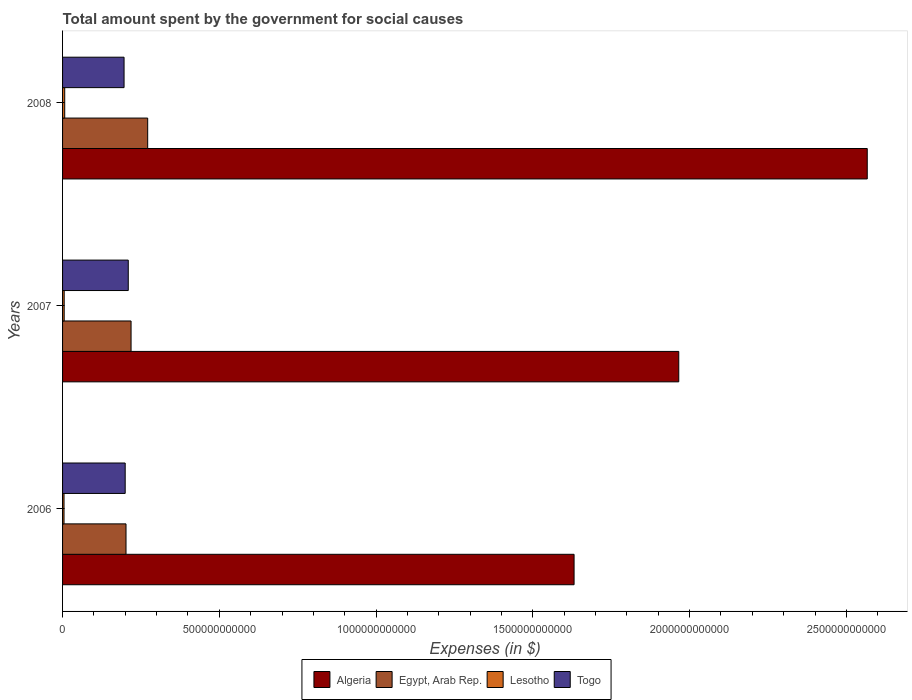How many different coloured bars are there?
Offer a terse response. 4. Are the number of bars per tick equal to the number of legend labels?
Provide a short and direct response. Yes. Are the number of bars on each tick of the Y-axis equal?
Give a very brief answer. Yes. How many bars are there on the 2nd tick from the top?
Make the answer very short. 4. How many bars are there on the 3rd tick from the bottom?
Ensure brevity in your answer.  4. What is the label of the 2nd group of bars from the top?
Keep it short and to the point. 2007. In how many cases, is the number of bars for a given year not equal to the number of legend labels?
Keep it short and to the point. 0. What is the amount spent for social causes by the government in Togo in 2008?
Your response must be concise. 1.96e+11. Across all years, what is the maximum amount spent for social causes by the government in Lesotho?
Keep it short and to the point. 6.87e+09. Across all years, what is the minimum amount spent for social causes by the government in Togo?
Your answer should be compact. 1.96e+11. What is the total amount spent for social causes by the government in Lesotho in the graph?
Provide a succinct answer. 1.67e+1. What is the difference between the amount spent for social causes by the government in Algeria in 2007 and that in 2008?
Offer a very short reply. -6.01e+11. What is the difference between the amount spent for social causes by the government in Togo in 2008 and the amount spent for social causes by the government in Egypt, Arab Rep. in 2007?
Make the answer very short. -2.23e+1. What is the average amount spent for social causes by the government in Egypt, Arab Rep. per year?
Provide a succinct answer. 2.31e+11. In the year 2007, what is the difference between the amount spent for social causes by the government in Egypt, Arab Rep. and amount spent for social causes by the government in Togo?
Your response must be concise. 8.93e+09. In how many years, is the amount spent for social causes by the government in Egypt, Arab Rep. greater than 600000000000 $?
Provide a short and direct response. 0. What is the ratio of the amount spent for social causes by the government in Lesotho in 2006 to that in 2008?
Provide a succinct answer. 0.68. Is the amount spent for social causes by the government in Egypt, Arab Rep. in 2006 less than that in 2008?
Give a very brief answer. Yes. Is the difference between the amount spent for social causes by the government in Egypt, Arab Rep. in 2006 and 2007 greater than the difference between the amount spent for social causes by the government in Togo in 2006 and 2007?
Provide a succinct answer. No. What is the difference between the highest and the second highest amount spent for social causes by the government in Algeria?
Offer a very short reply. 6.01e+11. What is the difference between the highest and the lowest amount spent for social causes by the government in Algeria?
Your response must be concise. 9.35e+11. Is it the case that in every year, the sum of the amount spent for social causes by the government in Togo and amount spent for social causes by the government in Egypt, Arab Rep. is greater than the sum of amount spent for social causes by the government in Lesotho and amount spent for social causes by the government in Algeria?
Give a very brief answer. No. What does the 3rd bar from the top in 2007 represents?
Keep it short and to the point. Egypt, Arab Rep. What does the 3rd bar from the bottom in 2006 represents?
Ensure brevity in your answer.  Lesotho. Is it the case that in every year, the sum of the amount spent for social causes by the government in Lesotho and amount spent for social causes by the government in Togo is greater than the amount spent for social causes by the government in Egypt, Arab Rep.?
Your answer should be very brief. No. How many bars are there?
Ensure brevity in your answer.  12. What is the difference between two consecutive major ticks on the X-axis?
Your answer should be compact. 5.00e+11. Are the values on the major ticks of X-axis written in scientific E-notation?
Provide a succinct answer. No. Does the graph contain any zero values?
Your response must be concise. No. How are the legend labels stacked?
Provide a short and direct response. Horizontal. What is the title of the graph?
Offer a terse response. Total amount spent by the government for social causes. What is the label or title of the X-axis?
Keep it short and to the point. Expenses (in $). What is the Expenses (in $) of Algeria in 2006?
Provide a short and direct response. 1.63e+12. What is the Expenses (in $) in Egypt, Arab Rep. in 2006?
Offer a terse response. 2.02e+11. What is the Expenses (in $) of Lesotho in 2006?
Ensure brevity in your answer.  4.65e+09. What is the Expenses (in $) in Togo in 2006?
Give a very brief answer. 2.00e+11. What is the Expenses (in $) in Algeria in 2007?
Your response must be concise. 1.97e+12. What is the Expenses (in $) in Egypt, Arab Rep. in 2007?
Provide a short and direct response. 2.18e+11. What is the Expenses (in $) in Lesotho in 2007?
Keep it short and to the point. 5.18e+09. What is the Expenses (in $) of Togo in 2007?
Your response must be concise. 2.10e+11. What is the Expenses (in $) in Algeria in 2008?
Your response must be concise. 2.57e+12. What is the Expenses (in $) of Egypt, Arab Rep. in 2008?
Make the answer very short. 2.71e+11. What is the Expenses (in $) in Lesotho in 2008?
Your answer should be compact. 6.87e+09. What is the Expenses (in $) of Togo in 2008?
Ensure brevity in your answer.  1.96e+11. Across all years, what is the maximum Expenses (in $) in Algeria?
Provide a short and direct response. 2.57e+12. Across all years, what is the maximum Expenses (in $) of Egypt, Arab Rep.?
Provide a succinct answer. 2.71e+11. Across all years, what is the maximum Expenses (in $) of Lesotho?
Make the answer very short. 6.87e+09. Across all years, what is the maximum Expenses (in $) of Togo?
Make the answer very short. 2.10e+11. Across all years, what is the minimum Expenses (in $) in Algeria?
Give a very brief answer. 1.63e+12. Across all years, what is the minimum Expenses (in $) of Egypt, Arab Rep.?
Give a very brief answer. 2.02e+11. Across all years, what is the minimum Expenses (in $) of Lesotho?
Keep it short and to the point. 4.65e+09. Across all years, what is the minimum Expenses (in $) of Togo?
Give a very brief answer. 1.96e+11. What is the total Expenses (in $) of Algeria in the graph?
Give a very brief answer. 6.16e+12. What is the total Expenses (in $) of Egypt, Arab Rep. in the graph?
Make the answer very short. 6.92e+11. What is the total Expenses (in $) in Lesotho in the graph?
Your response must be concise. 1.67e+1. What is the total Expenses (in $) of Togo in the graph?
Your answer should be very brief. 6.05e+11. What is the difference between the Expenses (in $) of Algeria in 2006 and that in 2007?
Offer a terse response. -3.34e+11. What is the difference between the Expenses (in $) in Egypt, Arab Rep. in 2006 and that in 2007?
Make the answer very short. -1.61e+1. What is the difference between the Expenses (in $) of Lesotho in 2006 and that in 2007?
Make the answer very short. -5.30e+08. What is the difference between the Expenses (in $) of Togo in 2006 and that in 2007?
Make the answer very short. -9.82e+09. What is the difference between the Expenses (in $) in Algeria in 2006 and that in 2008?
Provide a short and direct response. -9.35e+11. What is the difference between the Expenses (in $) in Egypt, Arab Rep. in 2006 and that in 2008?
Provide a succinct answer. -6.91e+1. What is the difference between the Expenses (in $) in Lesotho in 2006 and that in 2008?
Give a very brief answer. -2.22e+09. What is the difference between the Expenses (in $) in Togo in 2006 and that in 2008?
Offer a very short reply. 3.59e+09. What is the difference between the Expenses (in $) of Algeria in 2007 and that in 2008?
Offer a terse response. -6.01e+11. What is the difference between the Expenses (in $) in Egypt, Arab Rep. in 2007 and that in 2008?
Give a very brief answer. -5.30e+1. What is the difference between the Expenses (in $) of Lesotho in 2007 and that in 2008?
Provide a short and direct response. -1.68e+09. What is the difference between the Expenses (in $) of Togo in 2007 and that in 2008?
Keep it short and to the point. 1.34e+1. What is the difference between the Expenses (in $) in Algeria in 2006 and the Expenses (in $) in Egypt, Arab Rep. in 2007?
Your response must be concise. 1.41e+12. What is the difference between the Expenses (in $) of Algeria in 2006 and the Expenses (in $) of Lesotho in 2007?
Your answer should be very brief. 1.63e+12. What is the difference between the Expenses (in $) in Algeria in 2006 and the Expenses (in $) in Togo in 2007?
Offer a terse response. 1.42e+12. What is the difference between the Expenses (in $) of Egypt, Arab Rep. in 2006 and the Expenses (in $) of Lesotho in 2007?
Make the answer very short. 1.97e+11. What is the difference between the Expenses (in $) of Egypt, Arab Rep. in 2006 and the Expenses (in $) of Togo in 2007?
Offer a terse response. -7.18e+09. What is the difference between the Expenses (in $) in Lesotho in 2006 and the Expenses (in $) in Togo in 2007?
Your response must be concise. -2.05e+11. What is the difference between the Expenses (in $) in Algeria in 2006 and the Expenses (in $) in Egypt, Arab Rep. in 2008?
Offer a terse response. 1.36e+12. What is the difference between the Expenses (in $) of Algeria in 2006 and the Expenses (in $) of Lesotho in 2008?
Give a very brief answer. 1.62e+12. What is the difference between the Expenses (in $) of Algeria in 2006 and the Expenses (in $) of Togo in 2008?
Offer a terse response. 1.44e+12. What is the difference between the Expenses (in $) in Egypt, Arab Rep. in 2006 and the Expenses (in $) in Lesotho in 2008?
Provide a short and direct response. 1.96e+11. What is the difference between the Expenses (in $) of Egypt, Arab Rep. in 2006 and the Expenses (in $) of Togo in 2008?
Offer a very short reply. 6.24e+09. What is the difference between the Expenses (in $) of Lesotho in 2006 and the Expenses (in $) of Togo in 2008?
Provide a short and direct response. -1.91e+11. What is the difference between the Expenses (in $) of Algeria in 2007 and the Expenses (in $) of Egypt, Arab Rep. in 2008?
Make the answer very short. 1.69e+12. What is the difference between the Expenses (in $) in Algeria in 2007 and the Expenses (in $) in Lesotho in 2008?
Your answer should be compact. 1.96e+12. What is the difference between the Expenses (in $) of Algeria in 2007 and the Expenses (in $) of Togo in 2008?
Your answer should be very brief. 1.77e+12. What is the difference between the Expenses (in $) of Egypt, Arab Rep. in 2007 and the Expenses (in $) of Lesotho in 2008?
Provide a short and direct response. 2.12e+11. What is the difference between the Expenses (in $) of Egypt, Arab Rep. in 2007 and the Expenses (in $) of Togo in 2008?
Ensure brevity in your answer.  2.23e+1. What is the difference between the Expenses (in $) in Lesotho in 2007 and the Expenses (in $) in Togo in 2008?
Give a very brief answer. -1.91e+11. What is the average Expenses (in $) of Algeria per year?
Ensure brevity in your answer.  2.05e+12. What is the average Expenses (in $) in Egypt, Arab Rep. per year?
Your answer should be compact. 2.31e+11. What is the average Expenses (in $) of Lesotho per year?
Provide a succinct answer. 5.57e+09. What is the average Expenses (in $) in Togo per year?
Your response must be concise. 2.02e+11. In the year 2006, what is the difference between the Expenses (in $) in Algeria and Expenses (in $) in Egypt, Arab Rep.?
Make the answer very short. 1.43e+12. In the year 2006, what is the difference between the Expenses (in $) of Algeria and Expenses (in $) of Lesotho?
Your response must be concise. 1.63e+12. In the year 2006, what is the difference between the Expenses (in $) of Algeria and Expenses (in $) of Togo?
Offer a very short reply. 1.43e+12. In the year 2006, what is the difference between the Expenses (in $) of Egypt, Arab Rep. and Expenses (in $) of Lesotho?
Offer a terse response. 1.98e+11. In the year 2006, what is the difference between the Expenses (in $) in Egypt, Arab Rep. and Expenses (in $) in Togo?
Your answer should be compact. 2.65e+09. In the year 2006, what is the difference between the Expenses (in $) of Lesotho and Expenses (in $) of Togo?
Give a very brief answer. -1.95e+11. In the year 2007, what is the difference between the Expenses (in $) in Algeria and Expenses (in $) in Egypt, Arab Rep.?
Provide a short and direct response. 1.75e+12. In the year 2007, what is the difference between the Expenses (in $) of Algeria and Expenses (in $) of Lesotho?
Give a very brief answer. 1.96e+12. In the year 2007, what is the difference between the Expenses (in $) in Algeria and Expenses (in $) in Togo?
Offer a very short reply. 1.76e+12. In the year 2007, what is the difference between the Expenses (in $) in Egypt, Arab Rep. and Expenses (in $) in Lesotho?
Provide a succinct answer. 2.13e+11. In the year 2007, what is the difference between the Expenses (in $) of Egypt, Arab Rep. and Expenses (in $) of Togo?
Offer a terse response. 8.93e+09. In the year 2007, what is the difference between the Expenses (in $) of Lesotho and Expenses (in $) of Togo?
Your answer should be very brief. -2.04e+11. In the year 2008, what is the difference between the Expenses (in $) of Algeria and Expenses (in $) of Egypt, Arab Rep.?
Offer a terse response. 2.30e+12. In the year 2008, what is the difference between the Expenses (in $) in Algeria and Expenses (in $) in Lesotho?
Provide a short and direct response. 2.56e+12. In the year 2008, what is the difference between the Expenses (in $) of Algeria and Expenses (in $) of Togo?
Offer a very short reply. 2.37e+12. In the year 2008, what is the difference between the Expenses (in $) of Egypt, Arab Rep. and Expenses (in $) of Lesotho?
Make the answer very short. 2.65e+11. In the year 2008, what is the difference between the Expenses (in $) of Egypt, Arab Rep. and Expenses (in $) of Togo?
Give a very brief answer. 7.54e+1. In the year 2008, what is the difference between the Expenses (in $) of Lesotho and Expenses (in $) of Togo?
Ensure brevity in your answer.  -1.89e+11. What is the ratio of the Expenses (in $) of Algeria in 2006 to that in 2007?
Provide a succinct answer. 0.83. What is the ratio of the Expenses (in $) in Egypt, Arab Rep. in 2006 to that in 2007?
Your response must be concise. 0.93. What is the ratio of the Expenses (in $) in Lesotho in 2006 to that in 2007?
Keep it short and to the point. 0.9. What is the ratio of the Expenses (in $) in Togo in 2006 to that in 2007?
Offer a very short reply. 0.95. What is the ratio of the Expenses (in $) of Algeria in 2006 to that in 2008?
Ensure brevity in your answer.  0.64. What is the ratio of the Expenses (in $) of Egypt, Arab Rep. in 2006 to that in 2008?
Keep it short and to the point. 0.75. What is the ratio of the Expenses (in $) of Lesotho in 2006 to that in 2008?
Your answer should be compact. 0.68. What is the ratio of the Expenses (in $) in Togo in 2006 to that in 2008?
Keep it short and to the point. 1.02. What is the ratio of the Expenses (in $) of Algeria in 2007 to that in 2008?
Make the answer very short. 0.77. What is the ratio of the Expenses (in $) in Egypt, Arab Rep. in 2007 to that in 2008?
Give a very brief answer. 0.8. What is the ratio of the Expenses (in $) of Lesotho in 2007 to that in 2008?
Your answer should be compact. 0.75. What is the ratio of the Expenses (in $) of Togo in 2007 to that in 2008?
Give a very brief answer. 1.07. What is the difference between the highest and the second highest Expenses (in $) of Algeria?
Your response must be concise. 6.01e+11. What is the difference between the highest and the second highest Expenses (in $) of Egypt, Arab Rep.?
Make the answer very short. 5.30e+1. What is the difference between the highest and the second highest Expenses (in $) of Lesotho?
Give a very brief answer. 1.68e+09. What is the difference between the highest and the second highest Expenses (in $) in Togo?
Your answer should be very brief. 9.82e+09. What is the difference between the highest and the lowest Expenses (in $) of Algeria?
Provide a succinct answer. 9.35e+11. What is the difference between the highest and the lowest Expenses (in $) in Egypt, Arab Rep.?
Ensure brevity in your answer.  6.91e+1. What is the difference between the highest and the lowest Expenses (in $) of Lesotho?
Provide a succinct answer. 2.22e+09. What is the difference between the highest and the lowest Expenses (in $) of Togo?
Make the answer very short. 1.34e+1. 